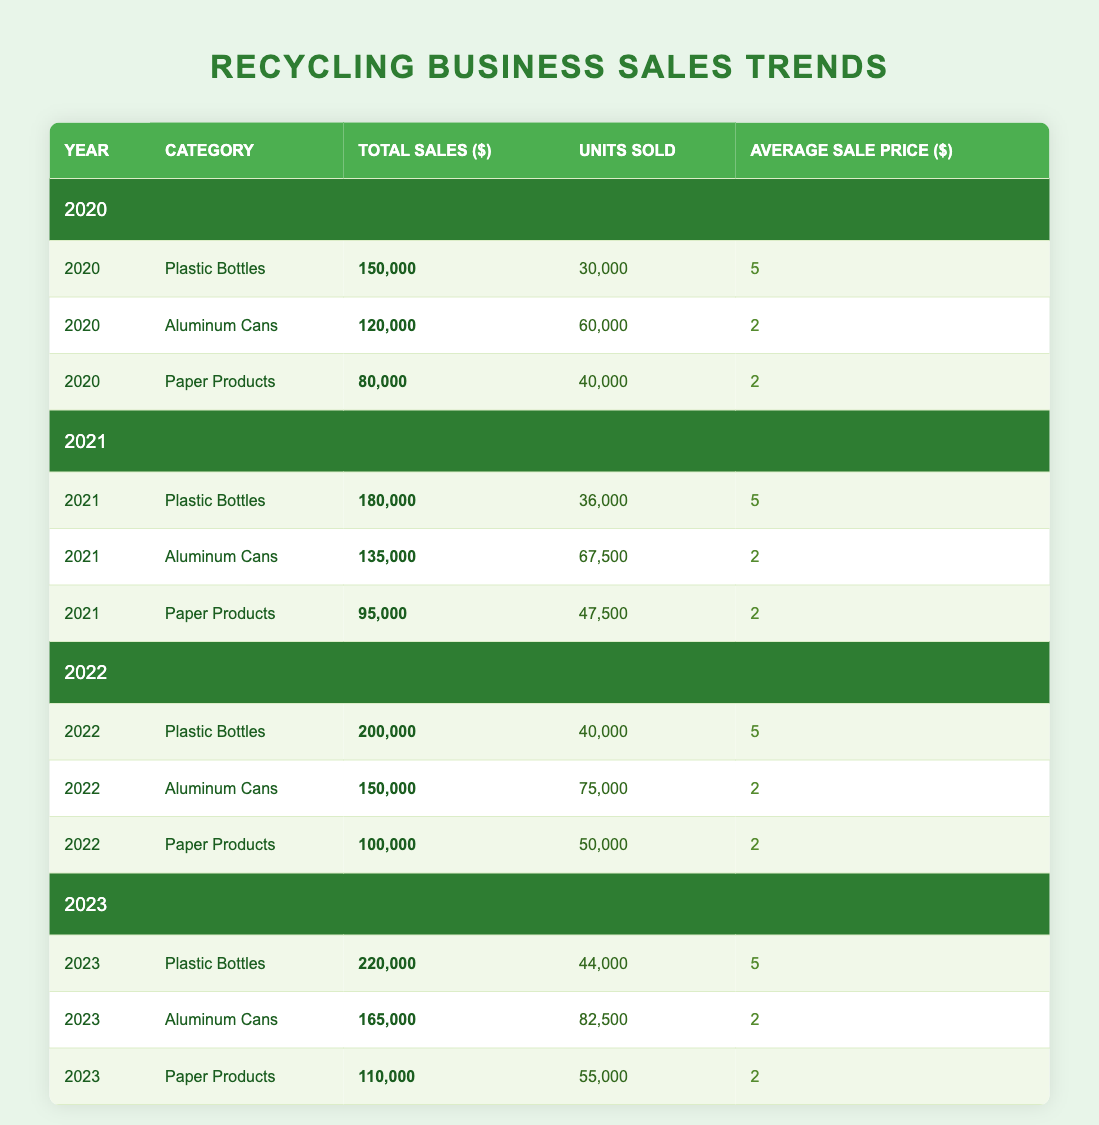What was the total sales for Aluminum Cans in 2022? In the row for the year 2022 under the category Aluminum Cans, the total sales are listed as 150,000.
Answer: 150,000 Which category had the highest total sales in 2023? In 2023, the total sales for Plastic Bottles are 220,000, which is the highest compared to Aluminum Cans at 165,000 and Paper Products at 110,000.
Answer: Plastic Bottles How many units of Paper Products were sold in 2021? In the row for the year 2021 under the category Paper Products, the units sold are listed as 47,500.
Answer: 47,500 What was the average sale price for Aluminum Cans from 2020 to 2023? The average sale price for Aluminum Cans is consistent at 2 dollars for all years, thus the average price over the period is simply 2.
Answer: 2 Was there an increase in total sales for Plastic Bottles from 2020 to 2023? The total sales for Plastic Bottles were 150,000 in 2020 and increased to 220,000 in 2023, which indicates an increase.
Answer: Yes What is the percentage increase in total sales for Paper Products from 2021 to 2022? The total sales for Paper Products were 95,000 in 2021 and grew to 100,000 in 2022. The increase is 100,000 - 95,000 = 5,000. The percentage increase is (5,000/95,000) * 100 = 5.26%.
Answer: 5.26% In which year were the total sales for Aluminum Cans the lowest? When checking the total sales for Aluminum Cans, it was 120,000 in 2020, 135,000 in 2021, 150,000 in 2022, and 165,000 in 2023. Hence, 2020 had the lowest sales.
Answer: 2020 How many total units of all categories were sold in 2022? To find the total units sold in 2022, add the units sold for each category: Plastic Bottles (40,000) + Aluminum Cans (75,000) + Paper Products (50,000) = 165,000.
Answer: 165,000 Did the average sale price for Plastic Bottles change from 2020 to 2023? The average sale price for Plastic Bottles was 5 dollars in both 2020 and 2023, indicating no change.
Answer: No 